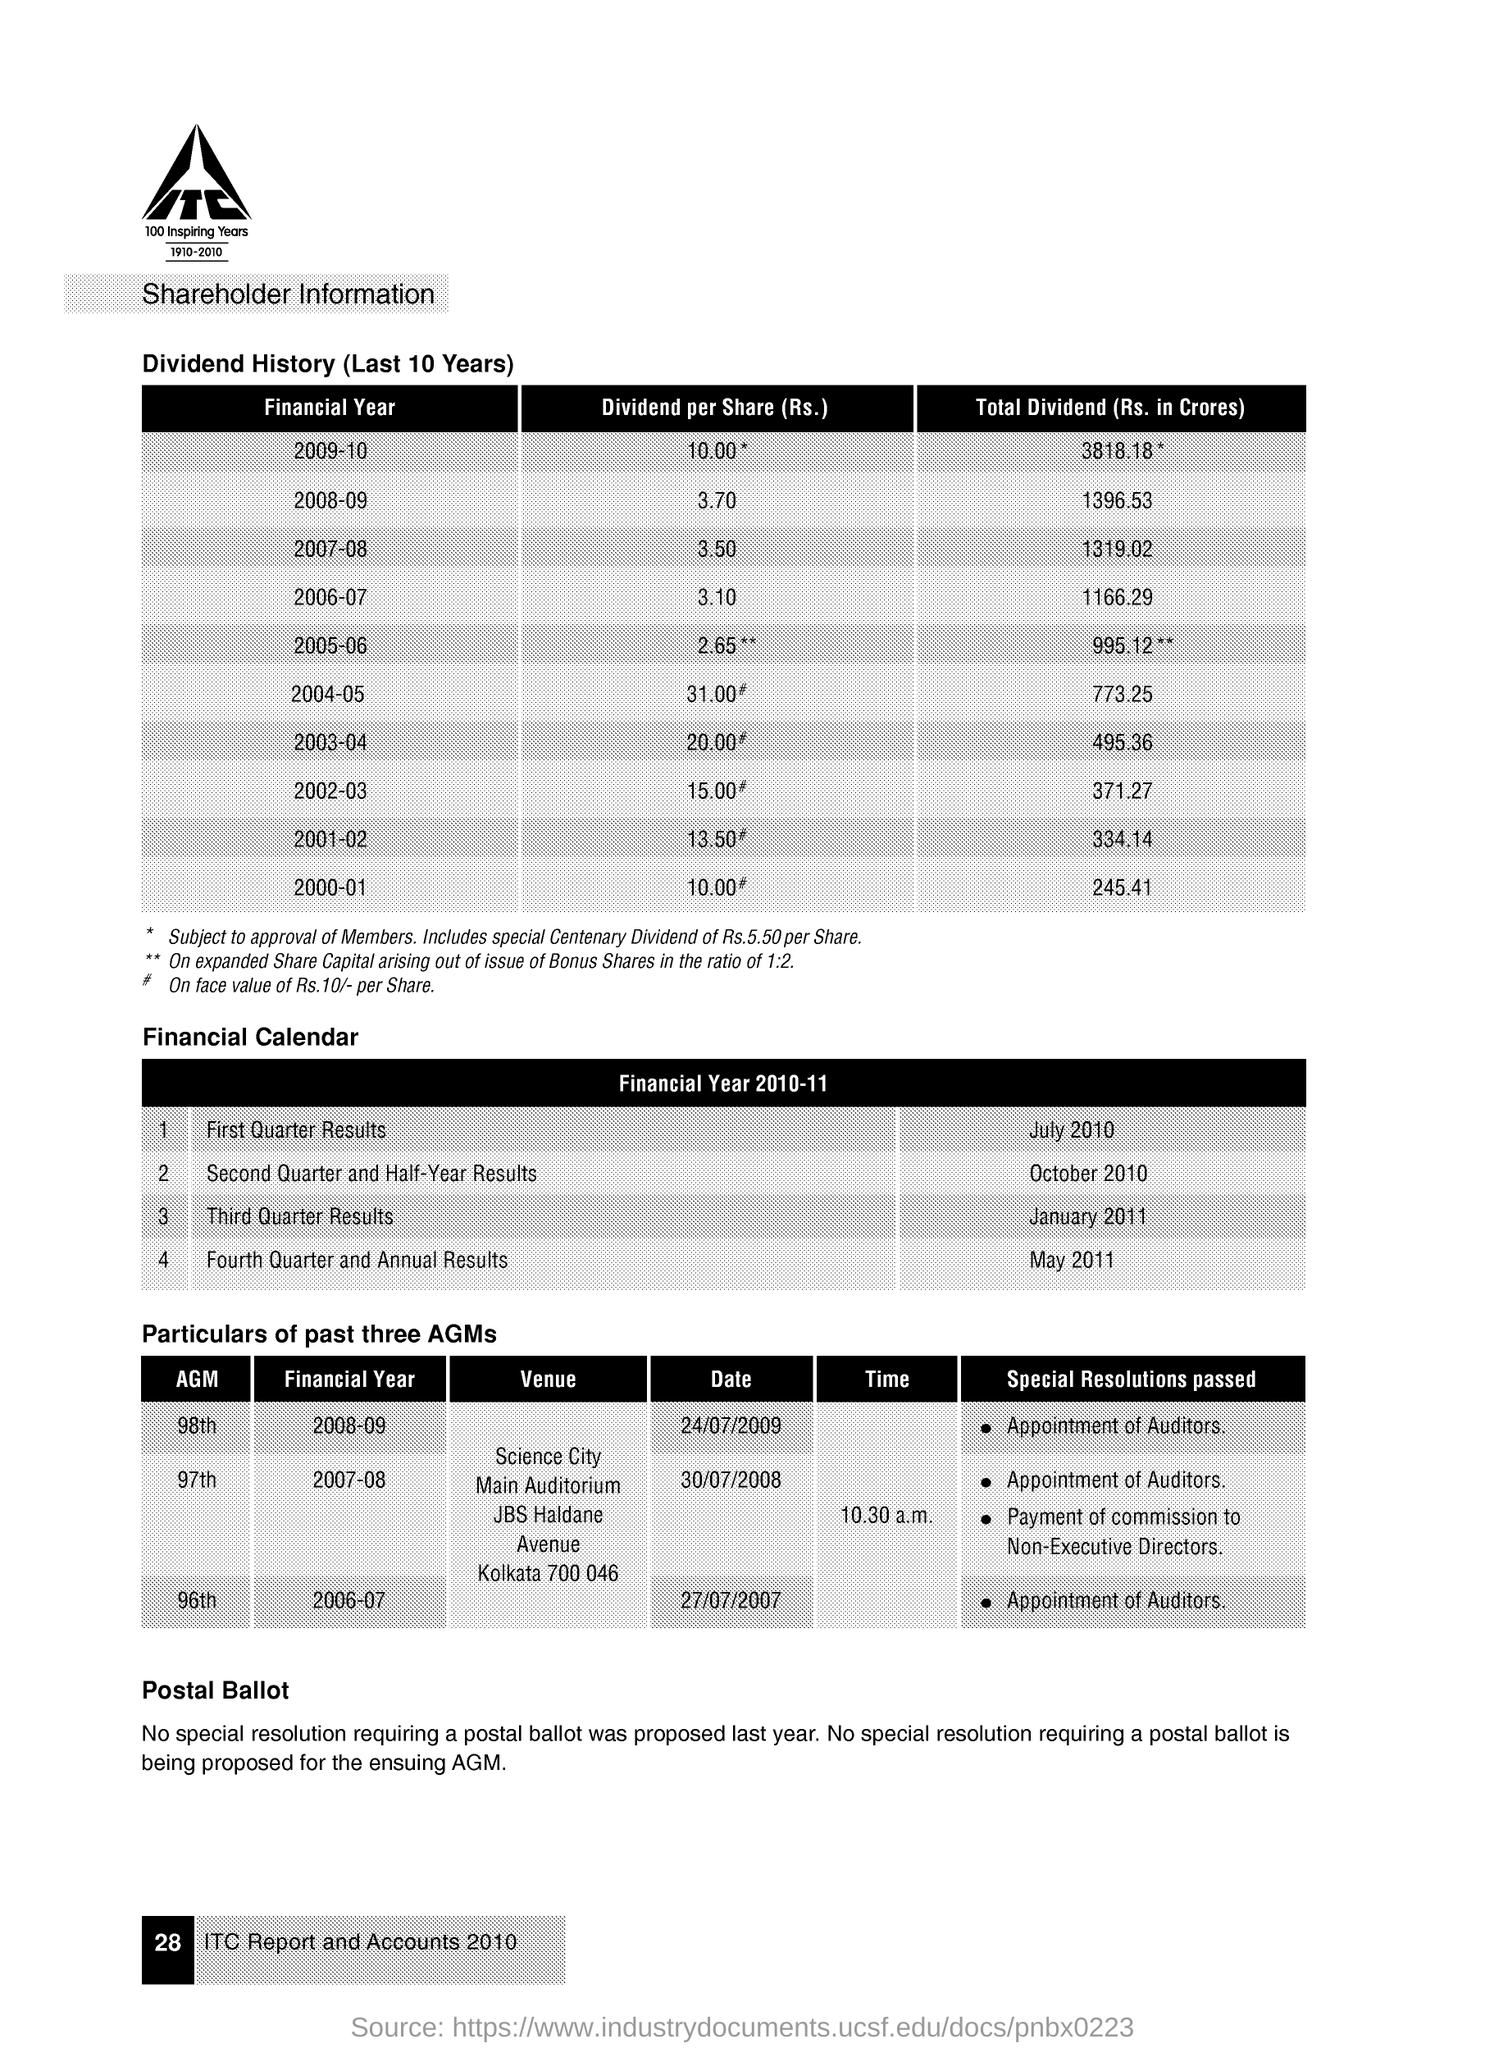What additional information does the image provide about the company's annual general meetings (AGMs)? The image provides details about the past three Annual General Meetings (AGMs) of the company. It lists the financial year each AGM corresponds to, the venue, the date, time, and any special resolutions passed. For example, the 98th AGM in the Financial Year 2008-09 took place at Science City, had the appointment of auditors as a special resolution passed, and occurred on 24/07/2009. 